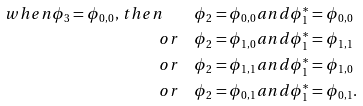Convert formula to latex. <formula><loc_0><loc_0><loc_500><loc_500>w h e n \phi _ { 3 } = \phi _ { 0 , 0 } , \, t h e n \quad & \phi _ { 2 } = \phi _ { 0 , 0 } a n d \phi ^ { * } _ { 1 } = \phi _ { 0 , 0 } \\ o r \quad & \phi _ { 2 } = \phi _ { 1 , 0 } a n d \phi ^ { * } _ { 1 } = \phi _ { 1 , 1 } \\ o r \quad & \phi _ { 2 } = \phi _ { 1 , 1 } a n d \phi ^ { * } _ { 1 } = \phi _ { 1 , 0 } \\ o r \quad & \phi _ { 2 } = \phi _ { 0 , 1 } a n d \phi ^ { * } _ { 1 } = \phi _ { 0 , 1 } .</formula> 